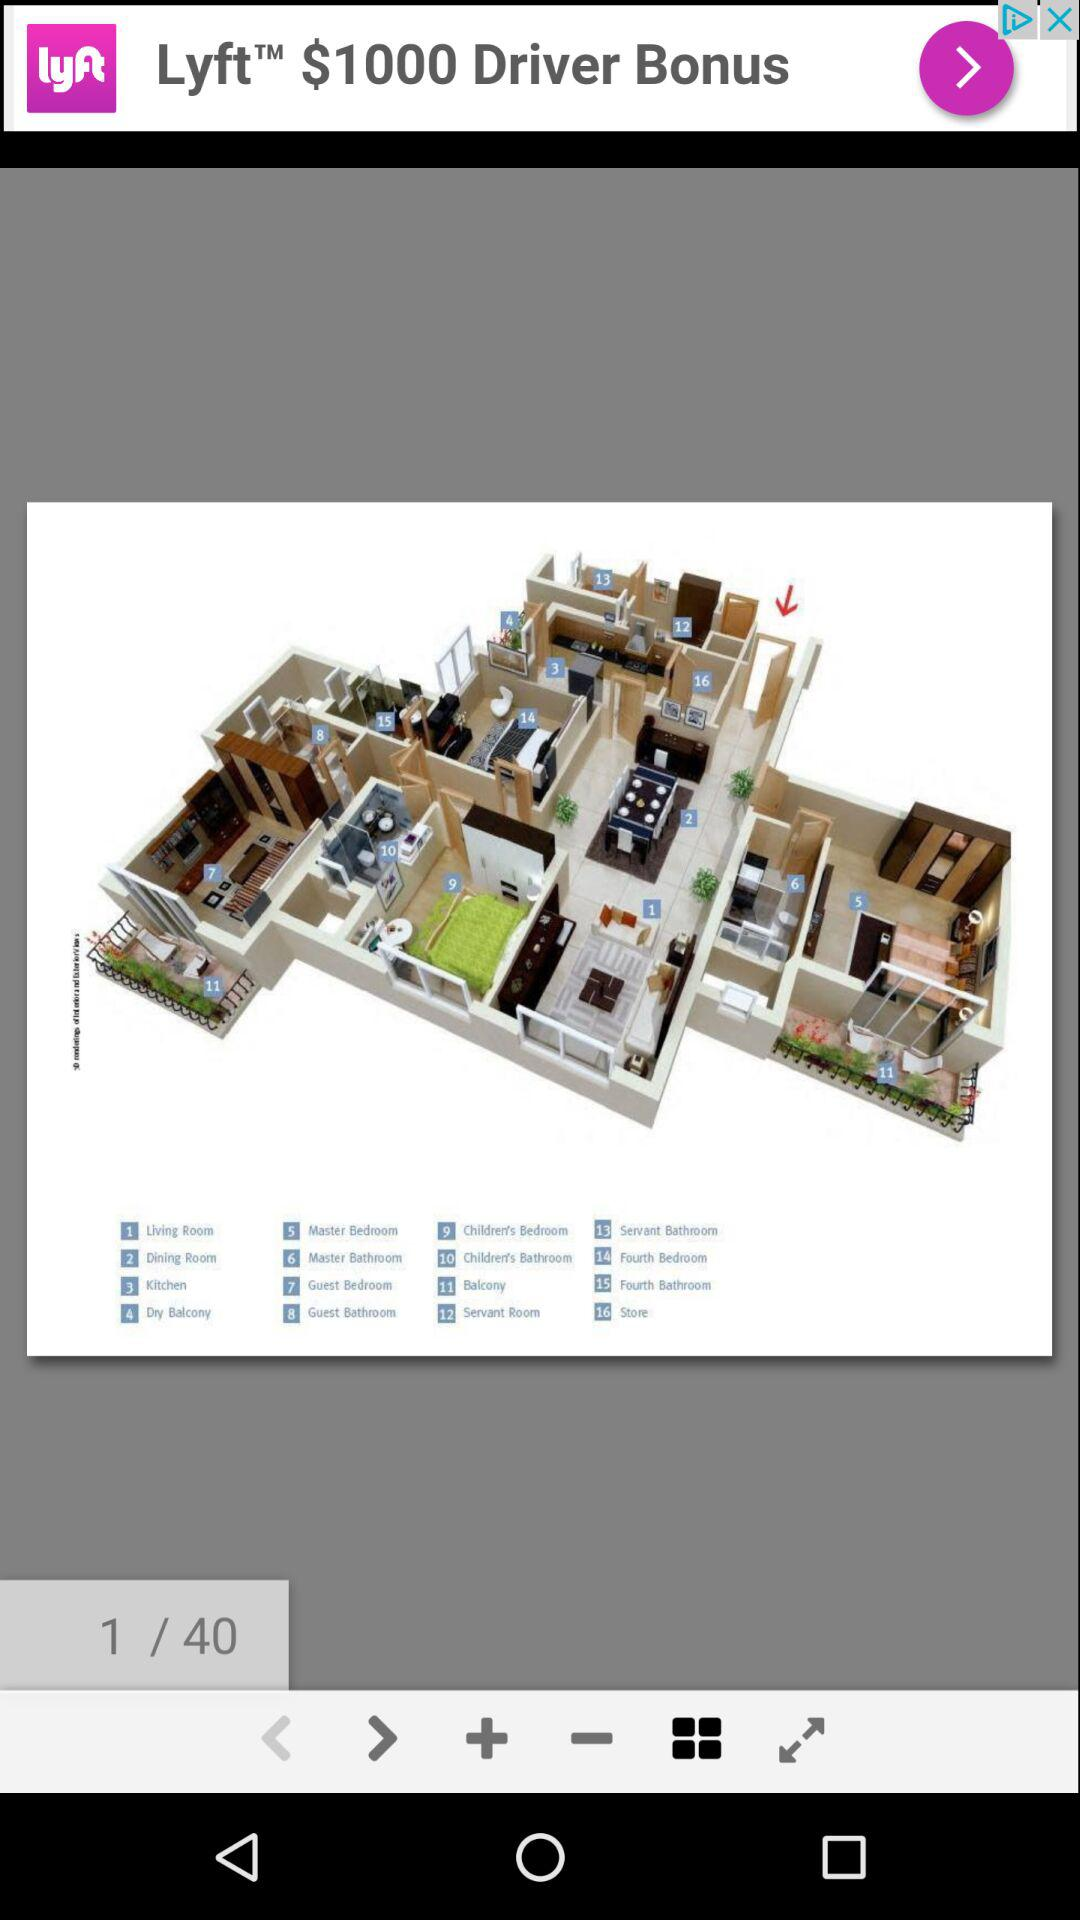How many images in total are there? There are 40 images in total. 